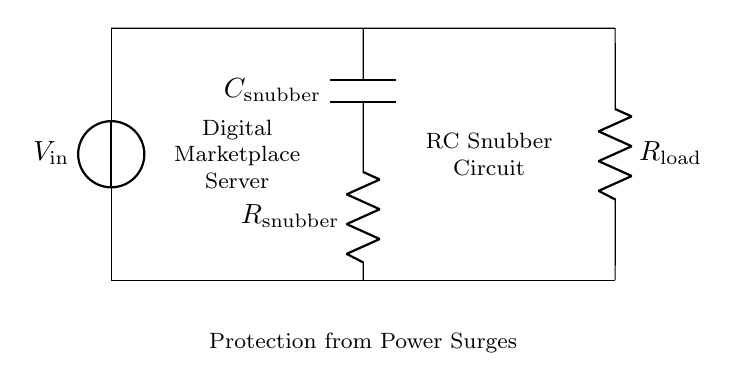What is the input voltage labeled in the circuit? The input voltage is labeled as V_in, indicating the voltage source connected at the left side of the circuit.
Answer: V_in What type of circuit is depicted in the diagram? The circuit is an RC snubber circuit, which consists of a resistor and capacitor in series connected to a digital marketplace server for surge protection.
Answer: RC snubber What component is used for surge protection in this circuit? The component used for surge protection here is the series combination of the resistor and capacitor, collectively known as the snubber.
Answer: Resistor and capacitor What is the role of R_load in this circuit? R_load represents the load resistance of the digital marketplace server, and its purpose is to simulate the operational load that the circuit will serve.
Answer: Load resistance How many primary components are there in the RC snubber? There are two primary components in the RC snubber: the resistor (R_snubber) and the capacitor (C_snubber).
Answer: Two Explain how the snubber circuit helps protect the server. The snubber circuit absorbs and dissipates excess transient voltage spikes, preventing potentially damaging voltage levels from reaching the digital marketplace server. This is achieved by converting the energy from transients into heat across the resistor and capacitor.
Answer: Absorbs transients What is the output voltage at the load? The output voltage at the load R_load is V_in minus the voltage drop across R_snubber and C_snubber during a surge event. It will vary with the frequency and duration of the surge.
Answer: V_in - V_drop 